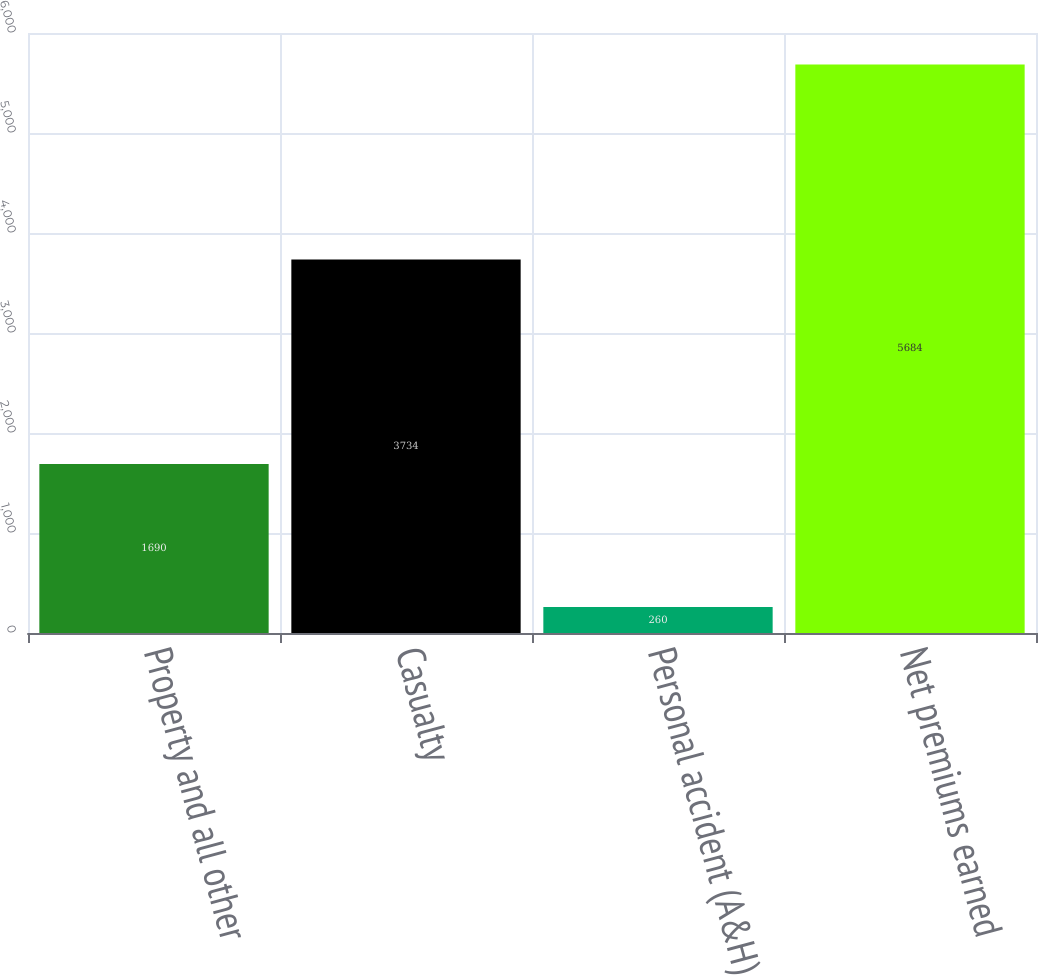<chart> <loc_0><loc_0><loc_500><loc_500><bar_chart><fcel>Property and all other<fcel>Casualty<fcel>Personal accident (A&H)<fcel>Net premiums earned<nl><fcel>1690<fcel>3734<fcel>260<fcel>5684<nl></chart> 